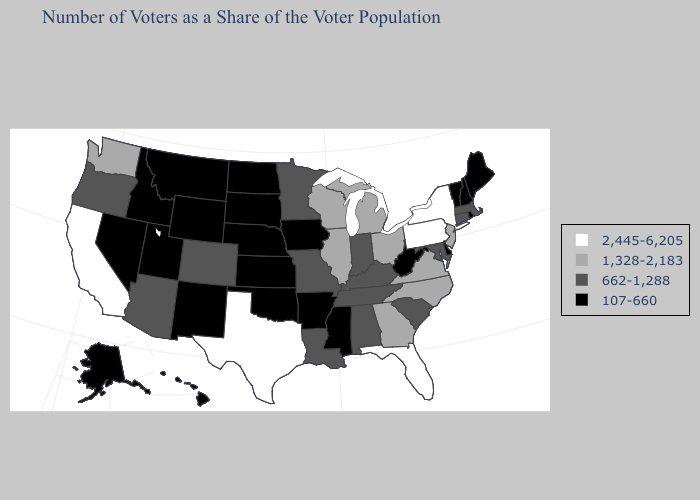Name the states that have a value in the range 107-660?
Give a very brief answer. Alaska, Arkansas, Delaware, Hawaii, Idaho, Iowa, Kansas, Maine, Mississippi, Montana, Nebraska, Nevada, New Hampshire, New Mexico, North Dakota, Oklahoma, Rhode Island, South Dakota, Utah, Vermont, West Virginia, Wyoming. Among the states that border South Dakota , does North Dakota have the highest value?
Answer briefly. No. Does the map have missing data?
Keep it brief. No. Does Alaska have the highest value in the USA?
Answer briefly. No. What is the value of Kentucky?
Concise answer only. 662-1,288. What is the value of Washington?
Keep it brief. 1,328-2,183. What is the value of Montana?
Concise answer only. 107-660. Among the states that border South Carolina , which have the lowest value?
Answer briefly. Georgia, North Carolina. What is the highest value in the USA?
Write a very short answer. 2,445-6,205. Which states have the lowest value in the USA?
Quick response, please. Alaska, Arkansas, Delaware, Hawaii, Idaho, Iowa, Kansas, Maine, Mississippi, Montana, Nebraska, Nevada, New Hampshire, New Mexico, North Dakota, Oklahoma, Rhode Island, South Dakota, Utah, Vermont, West Virginia, Wyoming. What is the value of New Mexico?
Short answer required. 107-660. What is the value of South Carolina?
Answer briefly. 662-1,288. What is the lowest value in the USA?
Answer briefly. 107-660. Which states have the lowest value in the South?
Be succinct. Arkansas, Delaware, Mississippi, Oklahoma, West Virginia. Does the map have missing data?
Answer briefly. No. 